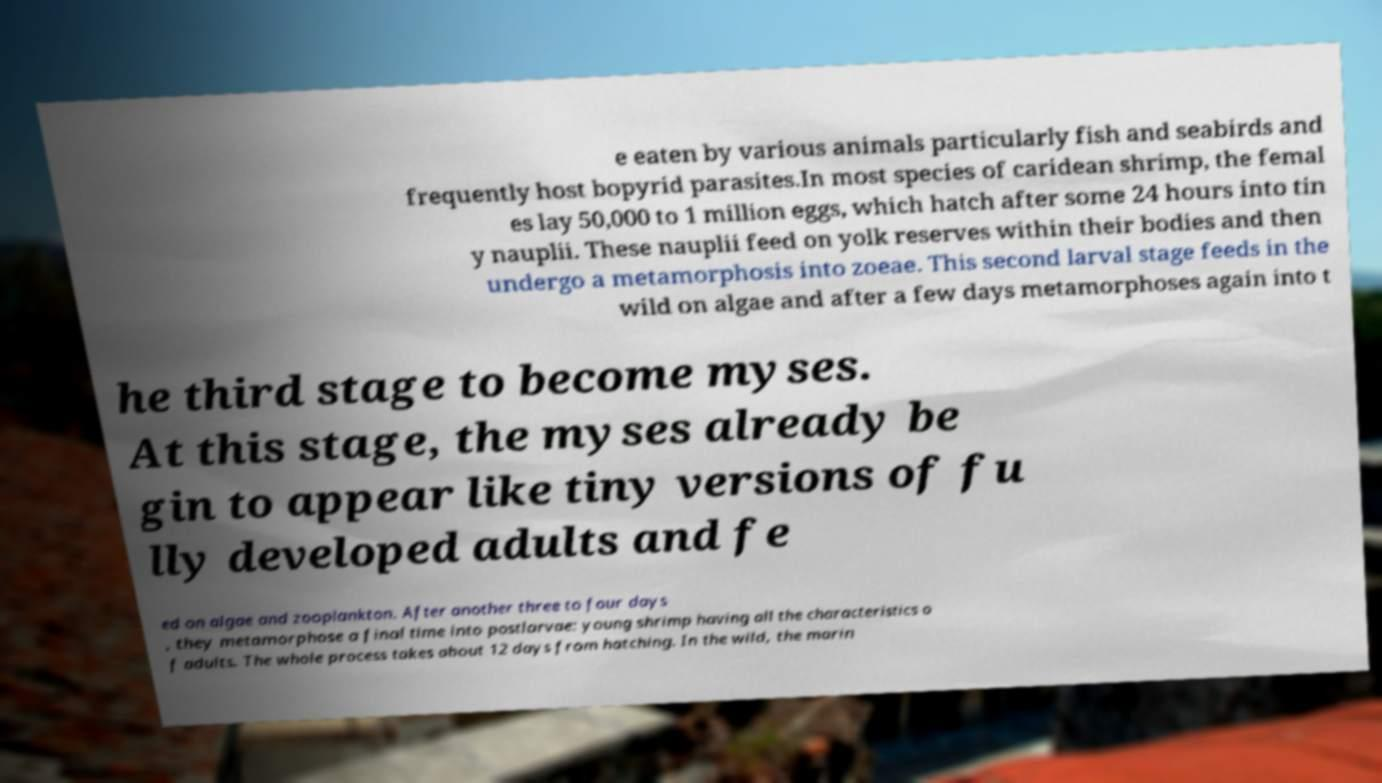Please read and relay the text visible in this image. What does it say? e eaten by various animals particularly fish and seabirds and frequently host bopyrid parasites.In most species of caridean shrimp, the femal es lay 50,000 to 1 million eggs, which hatch after some 24 hours into tin y nauplii. These nauplii feed on yolk reserves within their bodies and then undergo a metamorphosis into zoeae. This second larval stage feeds in the wild on algae and after a few days metamorphoses again into t he third stage to become myses. At this stage, the myses already be gin to appear like tiny versions of fu lly developed adults and fe ed on algae and zooplankton. After another three to four days , they metamorphose a final time into postlarvae: young shrimp having all the characteristics o f adults. The whole process takes about 12 days from hatching. In the wild, the marin 